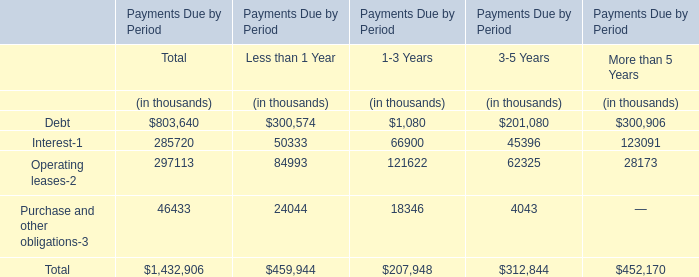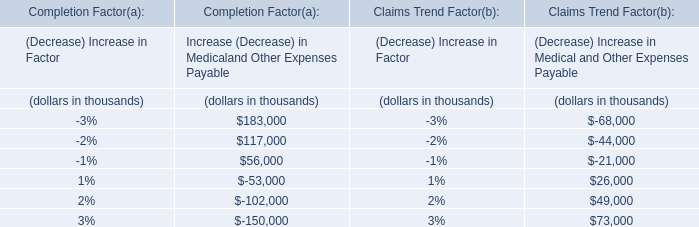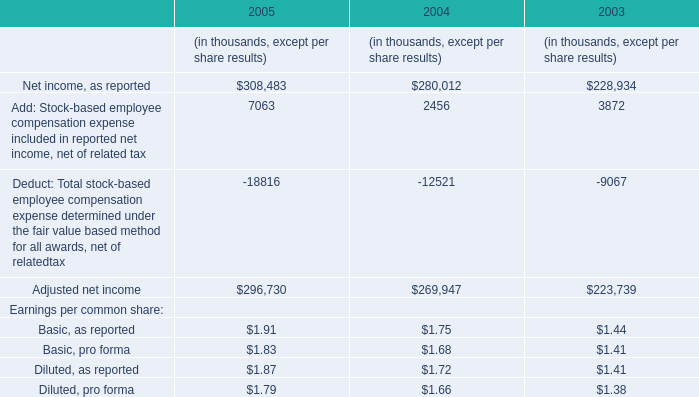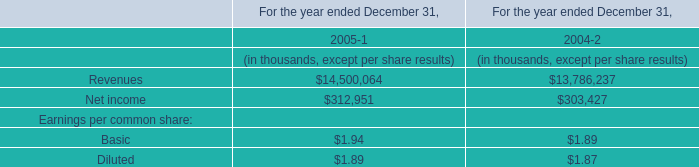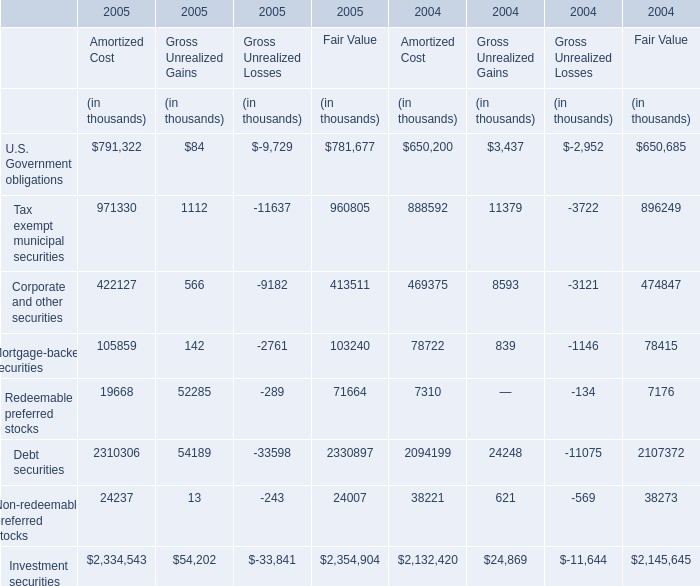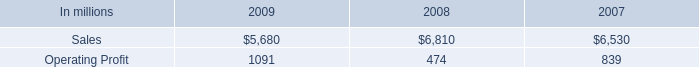Does the value of Revenues in 2004 greater than that in 2005? 
Answer: no. 